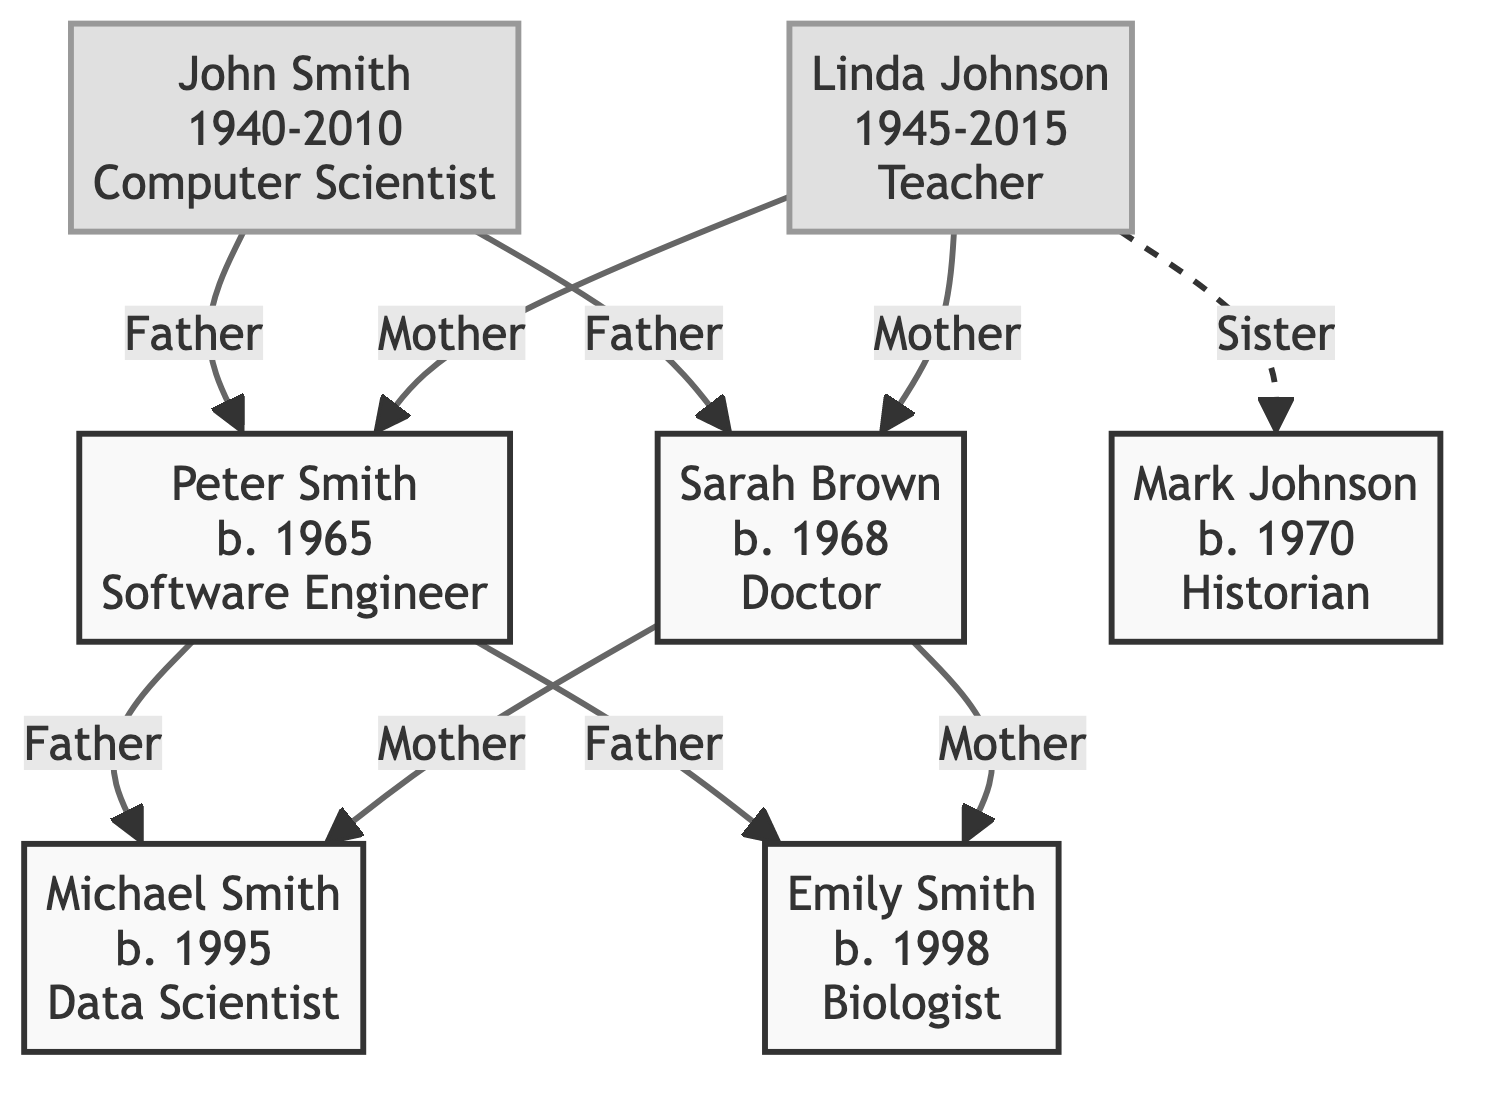What is the occupation of John Smith? The node representing John Smith states his occupation clearly in its description field. The text “Computer Scientist” indicates his occupation.
Answer: Computer Scientist How many children did Peter Smith have? In the diagram, Peter Smith is linked to two nodes (Michael Smith and Emily Smith), each indicating children through the "Father" relationship. Thus, he has two children.
Answer: 2 Who is the mother of Michael Smith? The diagram shows that both nodes for Sarah Brown and Peter Smith are labeled as parents of Michael Smith, indicating that Sarah Brown is his mother through the "Mother" relationship.
Answer: Sarah Brown In what year was Linda Johnson born? The node for Linda Johnson provides her birth year directly in its description, stating “Born: 1945”. Thus, her birth year is 1945.
Answer: 1945 What is the relationship between Linda Johnson and Mark Johnson? The diagram indicates a dashed connection labeled "Sister" from Linda Johnson to Mark Johnson, which denotes that she is his sister.
Answer: Sister How many deceased individuals are in the family tree? The diagram shows John Smith and Linda Johnson marked with the deceased class, so we count these two nodes to determine that there are two deceased individuals.
Answer: 2 Who are the children of Sarah Brown? We analyze the diagram to see that Sarah Brown has two children (Michael Smith and Emily Smith), as per the edges showing her "Mother" relationship.
Answer: Michael Smith and Emily Smith What is the occupation of Emily Smith? The node representing Emily Smith provides an occupation through its description, stating “Biologist,” which makes clear her professional role.
Answer: Biologist Who is the father of Peter Smith? The diagram connects Peter Smith to both John Smith and Linda Johnson, but since the question clarifies "father," we identify John Smith as he is explicitly labeled as such in the relationships.
Answer: John Smith 